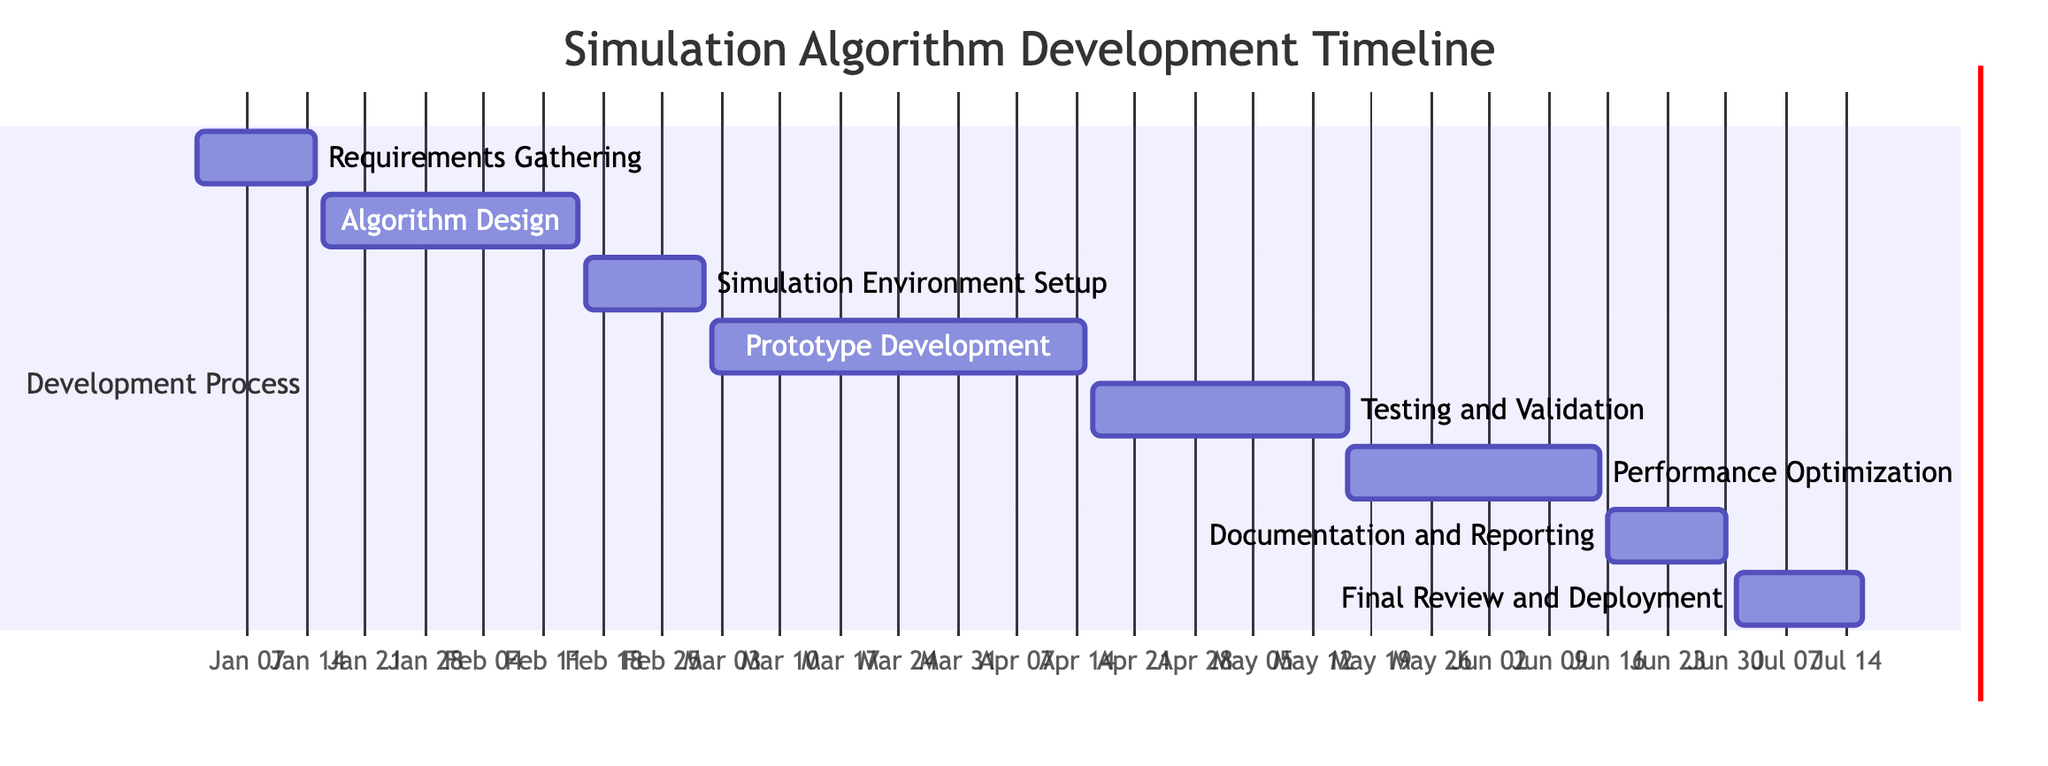What is the duration of the "Prototype Development" task? The duration of the "Prototype Development" task is provided directly in the data, which shows it lasts for 44 days.
Answer: 44 days When does "Algorithm Design" start? The start date for "Algorithm Design" is indicated in the data as January 16, 2024.
Answer: January 16, 2024 How many tasks are in the development process? There are eight tasks listed under the development process, as counted from the task data provided.
Answer: 8 What task follows "Testing and Validation"? Looking at the timeline, "Performance Optimization" follows "Testing and Validation" since it starts immediately after, on May 16, 2024.
Answer: Performance Optimization What is the overall duration from the start to the end of the project? The overall duration can be calculated from the start of "Requirements Gathering" (January 1, 2024) to the end of "Final Review and Deployment" (July 15, 2024), covering a total of 196 days.
Answer: 196 days Which task has the shortest duration? After reviewing the durations of all tasks, "Requirements Gathering" and "Documentation and Reporting" both have the shortest duration of 14 days.
Answer: 14 days Between which two tasks is there the largest gap in start dates? Checking the start dates, there is a gap between "Simulation Environment Setup" (February 16, 2024) and "Prototype Development" (March 2, 2024), giving a gap of 14 days.
Answer: Simulation Environment Setup and Prototype Development What is the final task in this timeline? According to the data listing the tasks in order, "Final Review and Deployment" is the last task that concludes the timeline.
Answer: Final Review and Deployment 